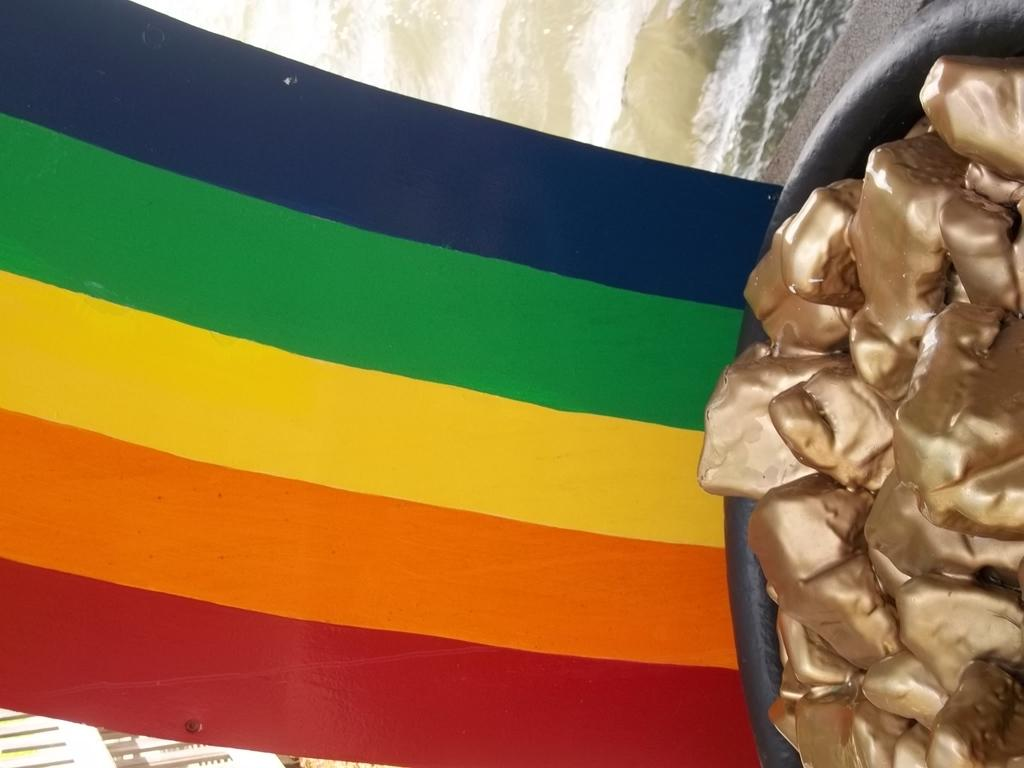What is present in the image? There is a cloth in the image. What type of bottle is being requested in the image? There is no bottle present in the image, nor is there any request being made. 